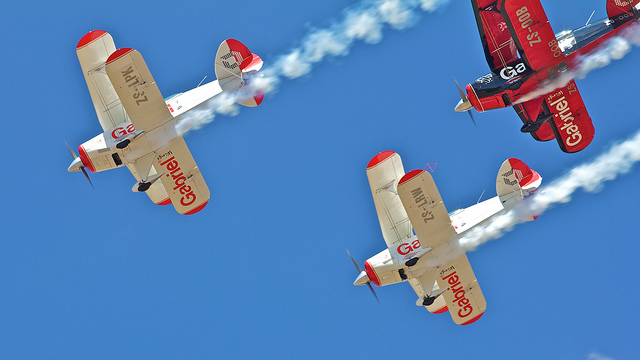What is trailing behind the airplanes? Behind each airplane, there is a distinct stream of smoke, likely used for visual effects in an aerobatic maneuver or airshow performance. 